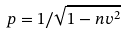Convert formula to latex. <formula><loc_0><loc_0><loc_500><loc_500>p = 1 / \sqrt { 1 - n v ^ { 2 } }</formula> 